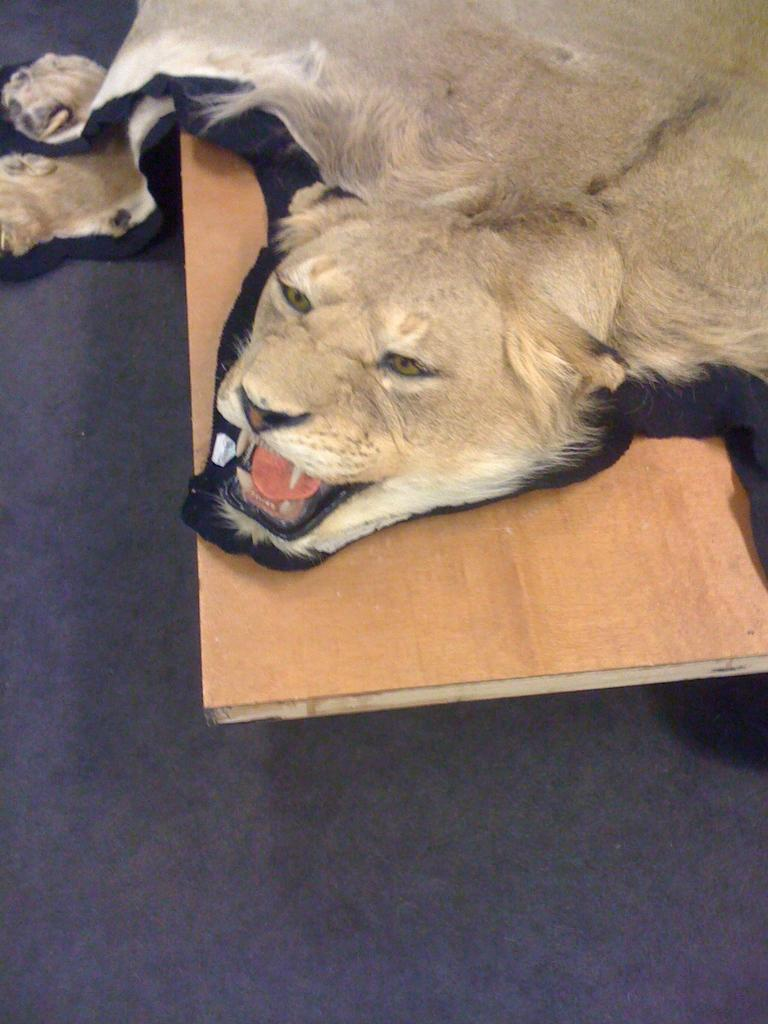What animal is the main subject of the image? There is a lion depicted in the image. What material is the lion resting on in the image? The lion is on wood, which could be a sculpture or an image. What is the surface below the lion in the image? The bottom part of the image is the floor. How many rails can be seen in the image? There are no rails present in the image. 